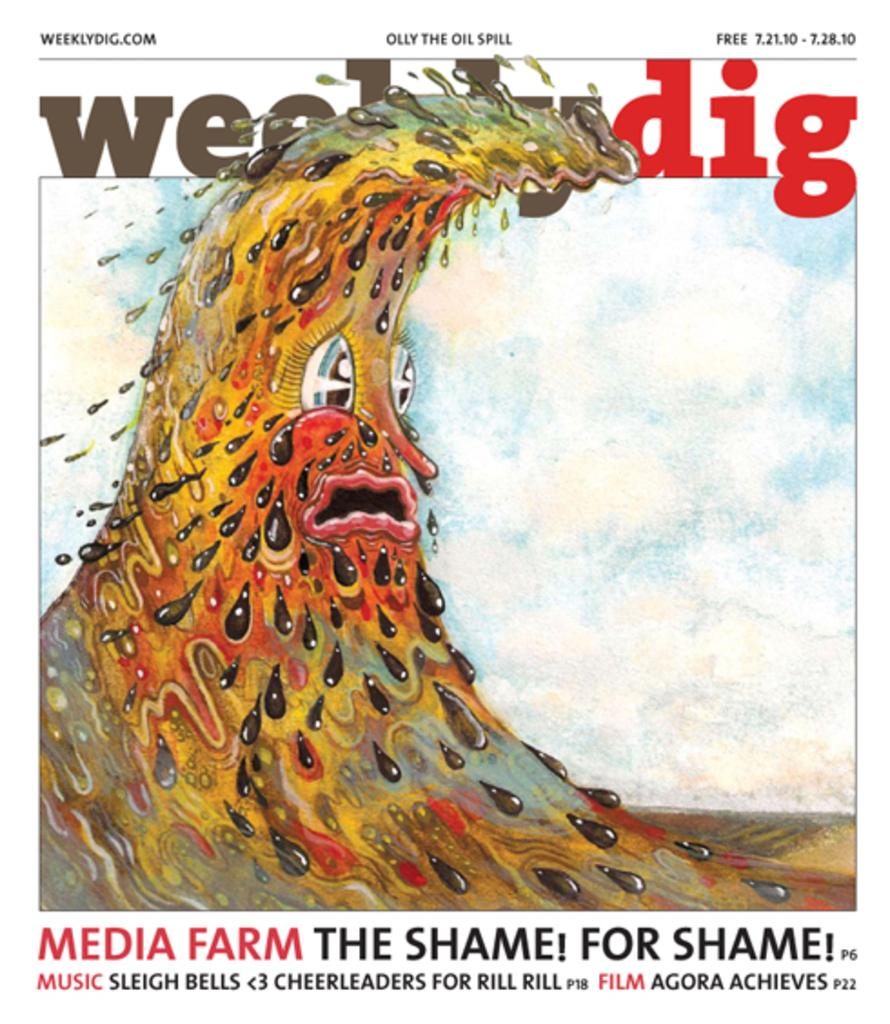Provide a one-sentence caption for the provided image. cover of the weeklydig magazine for 7.12.10 showing an illustration of  an anthropomorphic sludge wave. 